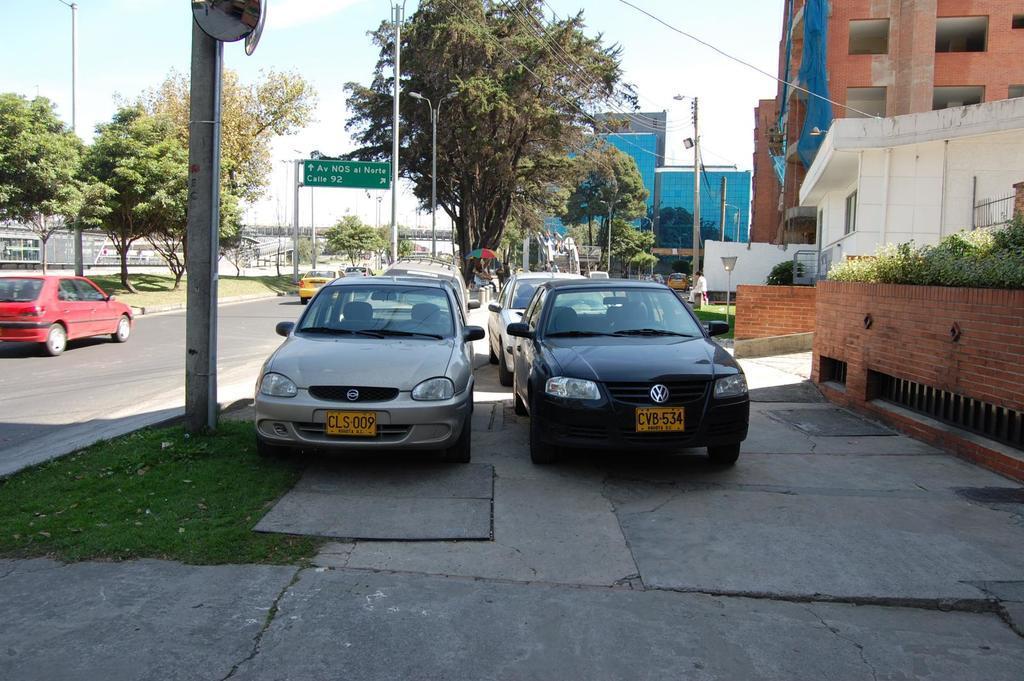Please provide a concise description of this image. In this picture there are cars in the center of the image and there is another car on the left side of the image and there are buildings on the right side of the image and there are trees and poles in the background area of the image, there is sign board in the background area of the image. 